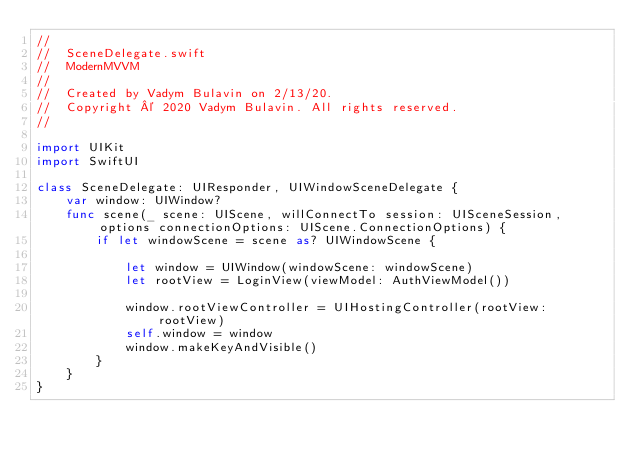<code> <loc_0><loc_0><loc_500><loc_500><_Swift_>//
//  SceneDelegate.swift
//  ModernMVVM
//
//  Created by Vadym Bulavin on 2/13/20.
//  Copyright © 2020 Vadym Bulavin. All rights reserved.
//

import UIKit
import SwiftUI

class SceneDelegate: UIResponder, UIWindowSceneDelegate {
    var window: UIWindow?
    func scene(_ scene: UIScene, willConnectTo session: UISceneSession, options connectionOptions: UIScene.ConnectionOptions) {
        if let windowScene = scene as? UIWindowScene {

            let window = UIWindow(windowScene: windowScene)
            let rootView = LoginView(viewModel: AuthViewModel())

            window.rootViewController = UIHostingController(rootView: rootView)
            self.window = window
            window.makeKeyAndVisible()
        }
    }
}

</code> 